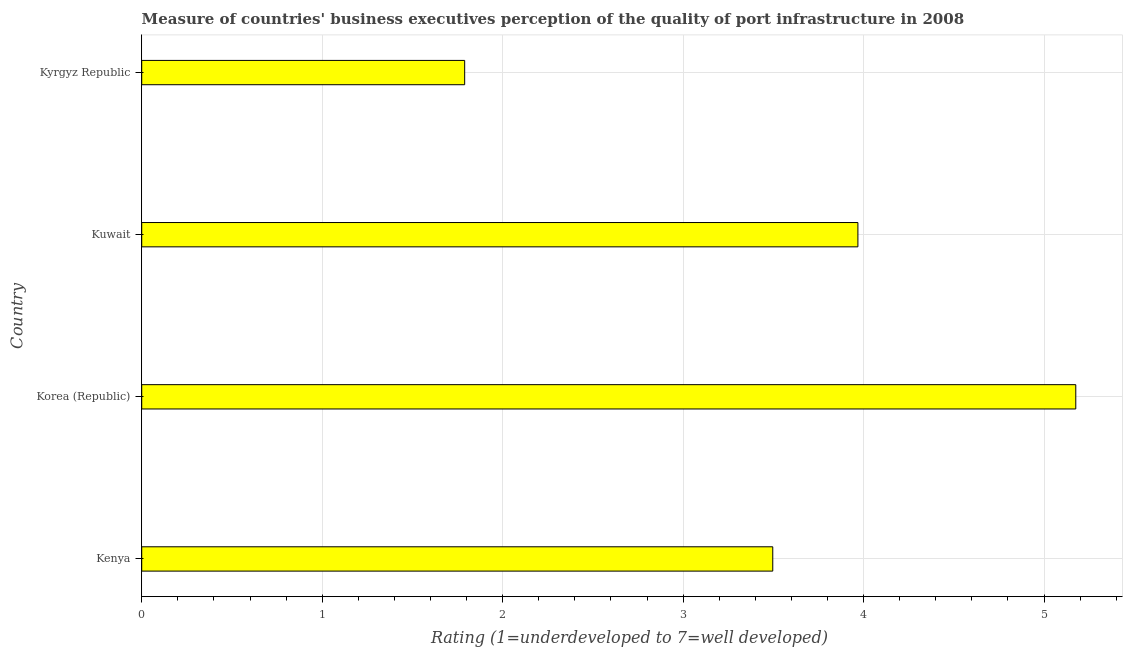Does the graph contain any zero values?
Keep it short and to the point. No. What is the title of the graph?
Your response must be concise. Measure of countries' business executives perception of the quality of port infrastructure in 2008. What is the label or title of the X-axis?
Offer a terse response. Rating (1=underdeveloped to 7=well developed) . What is the label or title of the Y-axis?
Offer a very short reply. Country. What is the rating measuring quality of port infrastructure in Kyrgyz Republic?
Your answer should be compact. 1.79. Across all countries, what is the maximum rating measuring quality of port infrastructure?
Provide a short and direct response. 5.18. Across all countries, what is the minimum rating measuring quality of port infrastructure?
Your answer should be compact. 1.79. In which country was the rating measuring quality of port infrastructure minimum?
Give a very brief answer. Kyrgyz Republic. What is the sum of the rating measuring quality of port infrastructure?
Offer a very short reply. 14.43. What is the difference between the rating measuring quality of port infrastructure in Korea (Republic) and Kuwait?
Keep it short and to the point. 1.21. What is the average rating measuring quality of port infrastructure per country?
Your answer should be very brief. 3.61. What is the median rating measuring quality of port infrastructure?
Offer a terse response. 3.73. What is the ratio of the rating measuring quality of port infrastructure in Kenya to that in Korea (Republic)?
Keep it short and to the point. 0.68. What is the difference between the highest and the second highest rating measuring quality of port infrastructure?
Offer a very short reply. 1.21. What is the difference between the highest and the lowest rating measuring quality of port infrastructure?
Ensure brevity in your answer.  3.39. Are all the bars in the graph horizontal?
Provide a short and direct response. Yes. How many countries are there in the graph?
Your answer should be compact. 4. What is the difference between two consecutive major ticks on the X-axis?
Offer a very short reply. 1. What is the Rating (1=underdeveloped to 7=well developed)  in Kenya?
Give a very brief answer. 3.5. What is the Rating (1=underdeveloped to 7=well developed)  in Korea (Republic)?
Your response must be concise. 5.18. What is the Rating (1=underdeveloped to 7=well developed)  in Kuwait?
Ensure brevity in your answer.  3.97. What is the Rating (1=underdeveloped to 7=well developed)  in Kyrgyz Republic?
Your answer should be very brief. 1.79. What is the difference between the Rating (1=underdeveloped to 7=well developed)  in Kenya and Korea (Republic)?
Your response must be concise. -1.68. What is the difference between the Rating (1=underdeveloped to 7=well developed)  in Kenya and Kuwait?
Offer a very short reply. -0.47. What is the difference between the Rating (1=underdeveloped to 7=well developed)  in Kenya and Kyrgyz Republic?
Provide a succinct answer. 1.71. What is the difference between the Rating (1=underdeveloped to 7=well developed)  in Korea (Republic) and Kuwait?
Your answer should be very brief. 1.21. What is the difference between the Rating (1=underdeveloped to 7=well developed)  in Korea (Republic) and Kyrgyz Republic?
Provide a succinct answer. 3.39. What is the difference between the Rating (1=underdeveloped to 7=well developed)  in Kuwait and Kyrgyz Republic?
Make the answer very short. 2.18. What is the ratio of the Rating (1=underdeveloped to 7=well developed)  in Kenya to that in Korea (Republic)?
Your answer should be very brief. 0.68. What is the ratio of the Rating (1=underdeveloped to 7=well developed)  in Kenya to that in Kuwait?
Offer a very short reply. 0.88. What is the ratio of the Rating (1=underdeveloped to 7=well developed)  in Kenya to that in Kyrgyz Republic?
Offer a terse response. 1.95. What is the ratio of the Rating (1=underdeveloped to 7=well developed)  in Korea (Republic) to that in Kuwait?
Your answer should be compact. 1.3. What is the ratio of the Rating (1=underdeveloped to 7=well developed)  in Korea (Republic) to that in Kyrgyz Republic?
Ensure brevity in your answer.  2.89. What is the ratio of the Rating (1=underdeveloped to 7=well developed)  in Kuwait to that in Kyrgyz Republic?
Offer a very short reply. 2.22. 